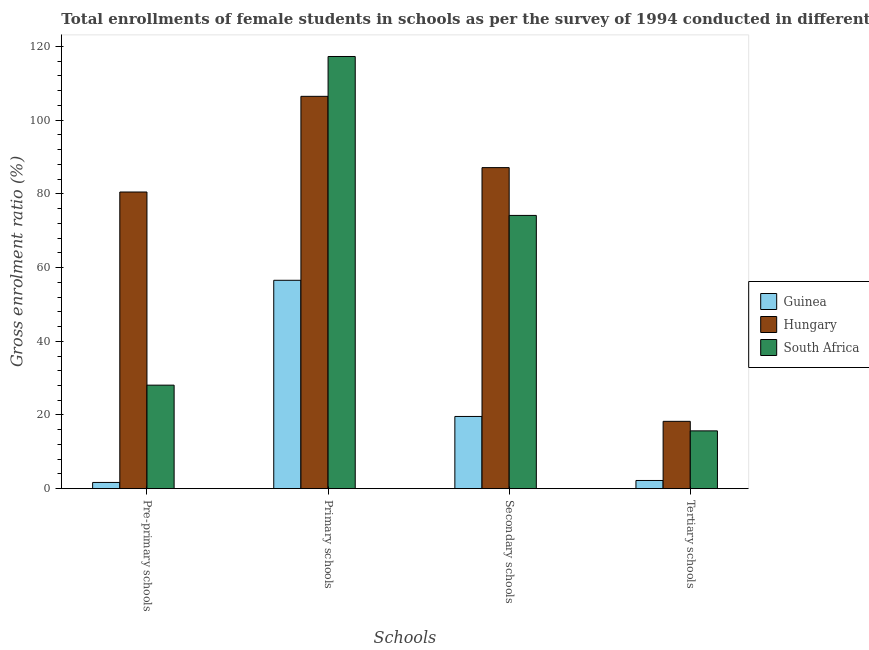How many groups of bars are there?
Offer a terse response. 4. Are the number of bars per tick equal to the number of legend labels?
Provide a succinct answer. Yes. What is the label of the 2nd group of bars from the left?
Your answer should be compact. Primary schools. What is the gross enrolment ratio(female) in secondary schools in Hungary?
Your answer should be compact. 87.13. Across all countries, what is the maximum gross enrolment ratio(female) in primary schools?
Your response must be concise. 117.29. Across all countries, what is the minimum gross enrolment ratio(female) in secondary schools?
Your answer should be very brief. 19.6. In which country was the gross enrolment ratio(female) in pre-primary schools maximum?
Ensure brevity in your answer.  Hungary. In which country was the gross enrolment ratio(female) in primary schools minimum?
Your answer should be very brief. Guinea. What is the total gross enrolment ratio(female) in pre-primary schools in the graph?
Make the answer very short. 110.3. What is the difference between the gross enrolment ratio(female) in primary schools in Guinea and that in Hungary?
Provide a short and direct response. -49.92. What is the difference between the gross enrolment ratio(female) in pre-primary schools in Guinea and the gross enrolment ratio(female) in secondary schools in Hungary?
Offer a very short reply. -85.44. What is the average gross enrolment ratio(female) in pre-primary schools per country?
Make the answer very short. 36.77. What is the difference between the gross enrolment ratio(female) in pre-primary schools and gross enrolment ratio(female) in tertiary schools in South Africa?
Your response must be concise. 12.41. What is the ratio of the gross enrolment ratio(female) in primary schools in Guinea to that in Hungary?
Ensure brevity in your answer.  0.53. Is the gross enrolment ratio(female) in pre-primary schools in South Africa less than that in Guinea?
Make the answer very short. No. Is the difference between the gross enrolment ratio(female) in tertiary schools in South Africa and Guinea greater than the difference between the gross enrolment ratio(female) in primary schools in South Africa and Guinea?
Make the answer very short. No. What is the difference between the highest and the second highest gross enrolment ratio(female) in primary schools?
Ensure brevity in your answer.  10.81. What is the difference between the highest and the lowest gross enrolment ratio(female) in secondary schools?
Give a very brief answer. 67.53. Is the sum of the gross enrolment ratio(female) in primary schools in South Africa and Hungary greater than the maximum gross enrolment ratio(female) in secondary schools across all countries?
Your response must be concise. Yes. What does the 2nd bar from the left in Pre-primary schools represents?
Provide a succinct answer. Hungary. What does the 1st bar from the right in Tertiary schools represents?
Provide a succinct answer. South Africa. Is it the case that in every country, the sum of the gross enrolment ratio(female) in pre-primary schools and gross enrolment ratio(female) in primary schools is greater than the gross enrolment ratio(female) in secondary schools?
Make the answer very short. Yes. Are all the bars in the graph horizontal?
Provide a short and direct response. No. Are the values on the major ticks of Y-axis written in scientific E-notation?
Offer a terse response. No. How many legend labels are there?
Provide a succinct answer. 3. What is the title of the graph?
Offer a terse response. Total enrollments of female students in schools as per the survey of 1994 conducted in different countries. Does "Congo (Republic)" appear as one of the legend labels in the graph?
Your answer should be very brief. No. What is the label or title of the X-axis?
Make the answer very short. Schools. What is the label or title of the Y-axis?
Give a very brief answer. Gross enrolment ratio (%). What is the Gross enrolment ratio (%) in Guinea in Pre-primary schools?
Provide a succinct answer. 1.69. What is the Gross enrolment ratio (%) in Hungary in Pre-primary schools?
Keep it short and to the point. 80.51. What is the Gross enrolment ratio (%) in South Africa in Pre-primary schools?
Your response must be concise. 28.1. What is the Gross enrolment ratio (%) in Guinea in Primary schools?
Your answer should be compact. 56.55. What is the Gross enrolment ratio (%) in Hungary in Primary schools?
Your response must be concise. 106.48. What is the Gross enrolment ratio (%) in South Africa in Primary schools?
Provide a succinct answer. 117.29. What is the Gross enrolment ratio (%) in Guinea in Secondary schools?
Your response must be concise. 19.6. What is the Gross enrolment ratio (%) in Hungary in Secondary schools?
Ensure brevity in your answer.  87.13. What is the Gross enrolment ratio (%) of South Africa in Secondary schools?
Make the answer very short. 74.16. What is the Gross enrolment ratio (%) in Guinea in Tertiary schools?
Offer a terse response. 2.22. What is the Gross enrolment ratio (%) in Hungary in Tertiary schools?
Make the answer very short. 18.27. What is the Gross enrolment ratio (%) of South Africa in Tertiary schools?
Make the answer very short. 15.69. Across all Schools, what is the maximum Gross enrolment ratio (%) of Guinea?
Your answer should be very brief. 56.55. Across all Schools, what is the maximum Gross enrolment ratio (%) of Hungary?
Your answer should be compact. 106.48. Across all Schools, what is the maximum Gross enrolment ratio (%) in South Africa?
Offer a terse response. 117.29. Across all Schools, what is the minimum Gross enrolment ratio (%) of Guinea?
Offer a very short reply. 1.69. Across all Schools, what is the minimum Gross enrolment ratio (%) of Hungary?
Offer a terse response. 18.27. Across all Schools, what is the minimum Gross enrolment ratio (%) of South Africa?
Offer a terse response. 15.69. What is the total Gross enrolment ratio (%) of Guinea in the graph?
Offer a very short reply. 80.06. What is the total Gross enrolment ratio (%) in Hungary in the graph?
Your response must be concise. 292.39. What is the total Gross enrolment ratio (%) of South Africa in the graph?
Give a very brief answer. 235.23. What is the difference between the Gross enrolment ratio (%) of Guinea in Pre-primary schools and that in Primary schools?
Provide a short and direct response. -54.86. What is the difference between the Gross enrolment ratio (%) in Hungary in Pre-primary schools and that in Primary schools?
Provide a short and direct response. -25.97. What is the difference between the Gross enrolment ratio (%) in South Africa in Pre-primary schools and that in Primary schools?
Your response must be concise. -89.19. What is the difference between the Gross enrolment ratio (%) of Guinea in Pre-primary schools and that in Secondary schools?
Your response must be concise. -17.9. What is the difference between the Gross enrolment ratio (%) of Hungary in Pre-primary schools and that in Secondary schools?
Provide a succinct answer. -6.62. What is the difference between the Gross enrolment ratio (%) of South Africa in Pre-primary schools and that in Secondary schools?
Your answer should be compact. -46.06. What is the difference between the Gross enrolment ratio (%) in Guinea in Pre-primary schools and that in Tertiary schools?
Make the answer very short. -0.53. What is the difference between the Gross enrolment ratio (%) in Hungary in Pre-primary schools and that in Tertiary schools?
Provide a succinct answer. 62.24. What is the difference between the Gross enrolment ratio (%) in South Africa in Pre-primary schools and that in Tertiary schools?
Provide a short and direct response. 12.41. What is the difference between the Gross enrolment ratio (%) in Guinea in Primary schools and that in Secondary schools?
Your answer should be very brief. 36.95. What is the difference between the Gross enrolment ratio (%) in Hungary in Primary schools and that in Secondary schools?
Give a very brief answer. 19.35. What is the difference between the Gross enrolment ratio (%) in South Africa in Primary schools and that in Secondary schools?
Keep it short and to the point. 43.13. What is the difference between the Gross enrolment ratio (%) of Guinea in Primary schools and that in Tertiary schools?
Ensure brevity in your answer.  54.33. What is the difference between the Gross enrolment ratio (%) of Hungary in Primary schools and that in Tertiary schools?
Make the answer very short. 88.2. What is the difference between the Gross enrolment ratio (%) in South Africa in Primary schools and that in Tertiary schools?
Give a very brief answer. 101.6. What is the difference between the Gross enrolment ratio (%) of Guinea in Secondary schools and that in Tertiary schools?
Provide a short and direct response. 17.37. What is the difference between the Gross enrolment ratio (%) of Hungary in Secondary schools and that in Tertiary schools?
Ensure brevity in your answer.  68.86. What is the difference between the Gross enrolment ratio (%) in South Africa in Secondary schools and that in Tertiary schools?
Offer a very short reply. 58.47. What is the difference between the Gross enrolment ratio (%) in Guinea in Pre-primary schools and the Gross enrolment ratio (%) in Hungary in Primary schools?
Your answer should be very brief. -104.78. What is the difference between the Gross enrolment ratio (%) in Guinea in Pre-primary schools and the Gross enrolment ratio (%) in South Africa in Primary schools?
Provide a succinct answer. -115.6. What is the difference between the Gross enrolment ratio (%) of Hungary in Pre-primary schools and the Gross enrolment ratio (%) of South Africa in Primary schools?
Offer a very short reply. -36.78. What is the difference between the Gross enrolment ratio (%) in Guinea in Pre-primary schools and the Gross enrolment ratio (%) in Hungary in Secondary schools?
Offer a terse response. -85.44. What is the difference between the Gross enrolment ratio (%) in Guinea in Pre-primary schools and the Gross enrolment ratio (%) in South Africa in Secondary schools?
Give a very brief answer. -72.47. What is the difference between the Gross enrolment ratio (%) of Hungary in Pre-primary schools and the Gross enrolment ratio (%) of South Africa in Secondary schools?
Provide a succinct answer. 6.35. What is the difference between the Gross enrolment ratio (%) of Guinea in Pre-primary schools and the Gross enrolment ratio (%) of Hungary in Tertiary schools?
Your response must be concise. -16.58. What is the difference between the Gross enrolment ratio (%) in Guinea in Pre-primary schools and the Gross enrolment ratio (%) in South Africa in Tertiary schools?
Make the answer very short. -13.99. What is the difference between the Gross enrolment ratio (%) of Hungary in Pre-primary schools and the Gross enrolment ratio (%) of South Africa in Tertiary schools?
Your answer should be very brief. 64.82. What is the difference between the Gross enrolment ratio (%) in Guinea in Primary schools and the Gross enrolment ratio (%) in Hungary in Secondary schools?
Ensure brevity in your answer.  -30.58. What is the difference between the Gross enrolment ratio (%) of Guinea in Primary schools and the Gross enrolment ratio (%) of South Africa in Secondary schools?
Give a very brief answer. -17.61. What is the difference between the Gross enrolment ratio (%) of Hungary in Primary schools and the Gross enrolment ratio (%) of South Africa in Secondary schools?
Your answer should be very brief. 32.32. What is the difference between the Gross enrolment ratio (%) in Guinea in Primary schools and the Gross enrolment ratio (%) in Hungary in Tertiary schools?
Offer a terse response. 38.28. What is the difference between the Gross enrolment ratio (%) in Guinea in Primary schools and the Gross enrolment ratio (%) in South Africa in Tertiary schools?
Offer a terse response. 40.87. What is the difference between the Gross enrolment ratio (%) of Hungary in Primary schools and the Gross enrolment ratio (%) of South Africa in Tertiary schools?
Offer a terse response. 90.79. What is the difference between the Gross enrolment ratio (%) in Guinea in Secondary schools and the Gross enrolment ratio (%) in Hungary in Tertiary schools?
Provide a short and direct response. 1.32. What is the difference between the Gross enrolment ratio (%) of Guinea in Secondary schools and the Gross enrolment ratio (%) of South Africa in Tertiary schools?
Ensure brevity in your answer.  3.91. What is the difference between the Gross enrolment ratio (%) in Hungary in Secondary schools and the Gross enrolment ratio (%) in South Africa in Tertiary schools?
Make the answer very short. 71.44. What is the average Gross enrolment ratio (%) of Guinea per Schools?
Your answer should be compact. 20.02. What is the average Gross enrolment ratio (%) in Hungary per Schools?
Make the answer very short. 73.1. What is the average Gross enrolment ratio (%) in South Africa per Schools?
Offer a terse response. 58.81. What is the difference between the Gross enrolment ratio (%) of Guinea and Gross enrolment ratio (%) of Hungary in Pre-primary schools?
Provide a succinct answer. -78.82. What is the difference between the Gross enrolment ratio (%) in Guinea and Gross enrolment ratio (%) in South Africa in Pre-primary schools?
Keep it short and to the point. -26.4. What is the difference between the Gross enrolment ratio (%) of Hungary and Gross enrolment ratio (%) of South Africa in Pre-primary schools?
Keep it short and to the point. 52.41. What is the difference between the Gross enrolment ratio (%) of Guinea and Gross enrolment ratio (%) of Hungary in Primary schools?
Offer a terse response. -49.92. What is the difference between the Gross enrolment ratio (%) in Guinea and Gross enrolment ratio (%) in South Africa in Primary schools?
Provide a short and direct response. -60.74. What is the difference between the Gross enrolment ratio (%) of Hungary and Gross enrolment ratio (%) of South Africa in Primary schools?
Provide a succinct answer. -10.81. What is the difference between the Gross enrolment ratio (%) of Guinea and Gross enrolment ratio (%) of Hungary in Secondary schools?
Provide a short and direct response. -67.53. What is the difference between the Gross enrolment ratio (%) in Guinea and Gross enrolment ratio (%) in South Africa in Secondary schools?
Offer a very short reply. -54.56. What is the difference between the Gross enrolment ratio (%) in Hungary and Gross enrolment ratio (%) in South Africa in Secondary schools?
Keep it short and to the point. 12.97. What is the difference between the Gross enrolment ratio (%) in Guinea and Gross enrolment ratio (%) in Hungary in Tertiary schools?
Offer a very short reply. -16.05. What is the difference between the Gross enrolment ratio (%) in Guinea and Gross enrolment ratio (%) in South Africa in Tertiary schools?
Give a very brief answer. -13.46. What is the difference between the Gross enrolment ratio (%) of Hungary and Gross enrolment ratio (%) of South Africa in Tertiary schools?
Keep it short and to the point. 2.59. What is the ratio of the Gross enrolment ratio (%) in Guinea in Pre-primary schools to that in Primary schools?
Provide a short and direct response. 0.03. What is the ratio of the Gross enrolment ratio (%) of Hungary in Pre-primary schools to that in Primary schools?
Offer a terse response. 0.76. What is the ratio of the Gross enrolment ratio (%) of South Africa in Pre-primary schools to that in Primary schools?
Provide a short and direct response. 0.24. What is the ratio of the Gross enrolment ratio (%) of Guinea in Pre-primary schools to that in Secondary schools?
Make the answer very short. 0.09. What is the ratio of the Gross enrolment ratio (%) in Hungary in Pre-primary schools to that in Secondary schools?
Provide a succinct answer. 0.92. What is the ratio of the Gross enrolment ratio (%) of South Africa in Pre-primary schools to that in Secondary schools?
Keep it short and to the point. 0.38. What is the ratio of the Gross enrolment ratio (%) of Guinea in Pre-primary schools to that in Tertiary schools?
Provide a short and direct response. 0.76. What is the ratio of the Gross enrolment ratio (%) of Hungary in Pre-primary schools to that in Tertiary schools?
Give a very brief answer. 4.41. What is the ratio of the Gross enrolment ratio (%) of South Africa in Pre-primary schools to that in Tertiary schools?
Provide a succinct answer. 1.79. What is the ratio of the Gross enrolment ratio (%) in Guinea in Primary schools to that in Secondary schools?
Your response must be concise. 2.89. What is the ratio of the Gross enrolment ratio (%) of Hungary in Primary schools to that in Secondary schools?
Give a very brief answer. 1.22. What is the ratio of the Gross enrolment ratio (%) of South Africa in Primary schools to that in Secondary schools?
Give a very brief answer. 1.58. What is the ratio of the Gross enrolment ratio (%) of Guinea in Primary schools to that in Tertiary schools?
Ensure brevity in your answer.  25.44. What is the ratio of the Gross enrolment ratio (%) in Hungary in Primary schools to that in Tertiary schools?
Give a very brief answer. 5.83. What is the ratio of the Gross enrolment ratio (%) in South Africa in Primary schools to that in Tertiary schools?
Give a very brief answer. 7.48. What is the ratio of the Gross enrolment ratio (%) in Guinea in Secondary schools to that in Tertiary schools?
Offer a terse response. 8.82. What is the ratio of the Gross enrolment ratio (%) in Hungary in Secondary schools to that in Tertiary schools?
Your response must be concise. 4.77. What is the ratio of the Gross enrolment ratio (%) in South Africa in Secondary schools to that in Tertiary schools?
Provide a succinct answer. 4.73. What is the difference between the highest and the second highest Gross enrolment ratio (%) in Guinea?
Give a very brief answer. 36.95. What is the difference between the highest and the second highest Gross enrolment ratio (%) in Hungary?
Your answer should be very brief. 19.35. What is the difference between the highest and the second highest Gross enrolment ratio (%) of South Africa?
Your answer should be very brief. 43.13. What is the difference between the highest and the lowest Gross enrolment ratio (%) in Guinea?
Keep it short and to the point. 54.86. What is the difference between the highest and the lowest Gross enrolment ratio (%) of Hungary?
Keep it short and to the point. 88.2. What is the difference between the highest and the lowest Gross enrolment ratio (%) in South Africa?
Make the answer very short. 101.6. 